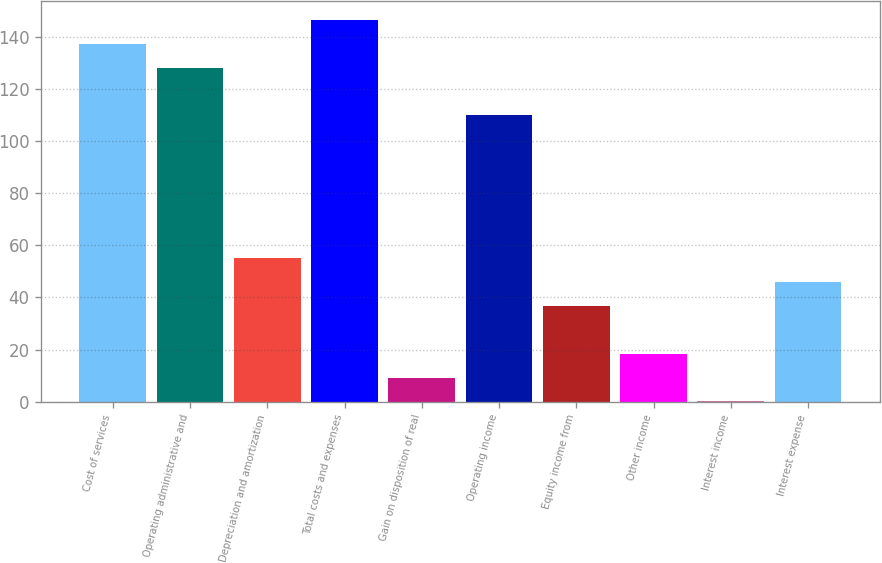Convert chart. <chart><loc_0><loc_0><loc_500><loc_500><bar_chart><fcel>Cost of services<fcel>Operating administrative and<fcel>Depreciation and amortization<fcel>Total costs and expenses<fcel>Gain on disposition of real<fcel>Operating income<fcel>Equity income from<fcel>Other income<fcel>Interest income<fcel>Interest expense<nl><fcel>137.35<fcel>128.2<fcel>55<fcel>146.5<fcel>9.25<fcel>109.9<fcel>36.7<fcel>18.4<fcel>0.1<fcel>45.85<nl></chart> 